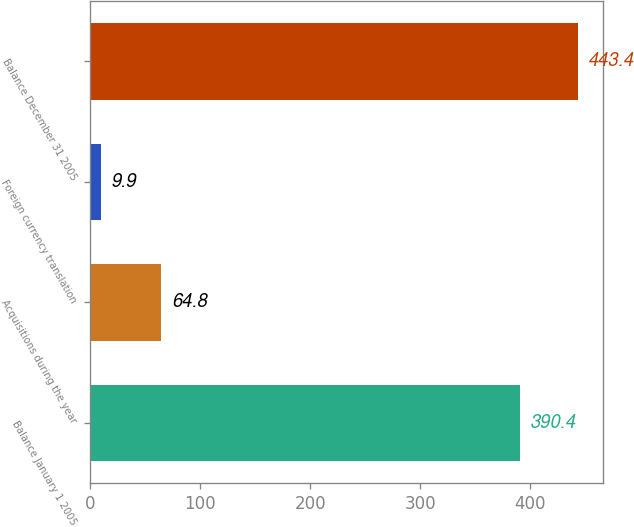<chart> <loc_0><loc_0><loc_500><loc_500><bar_chart><fcel>Balance January 1 2005<fcel>Acquisitions during the year<fcel>Foreign currency translation<fcel>Balance December 31 2005<nl><fcel>390.4<fcel>64.8<fcel>9.9<fcel>443.4<nl></chart> 